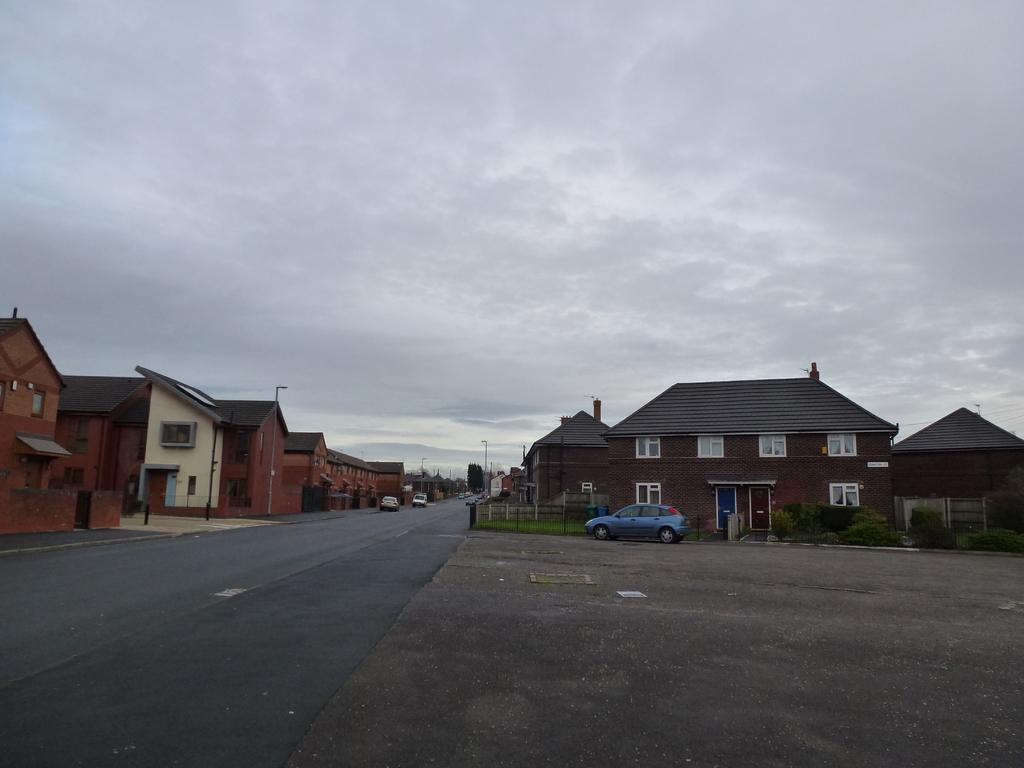What is the main feature of the image? There is a road in the image. What is happening on the road? There are vehicles on the road. What else can be seen in the image besides the road and vehicles? There are buildings, poles, street lights, and plants visible in the image. How is the sky depicted in the image? The sky is cloudy in the background of the image. How many books are stacked on the street light in the image? There are no books present in the image; it features a road, vehicles, buildings, poles, street lights, and plants. What type of property is being smashed by the vehicles in the image? There is no property being smashed by the vehicles in the image; the vehicles are simply driving on the road. 